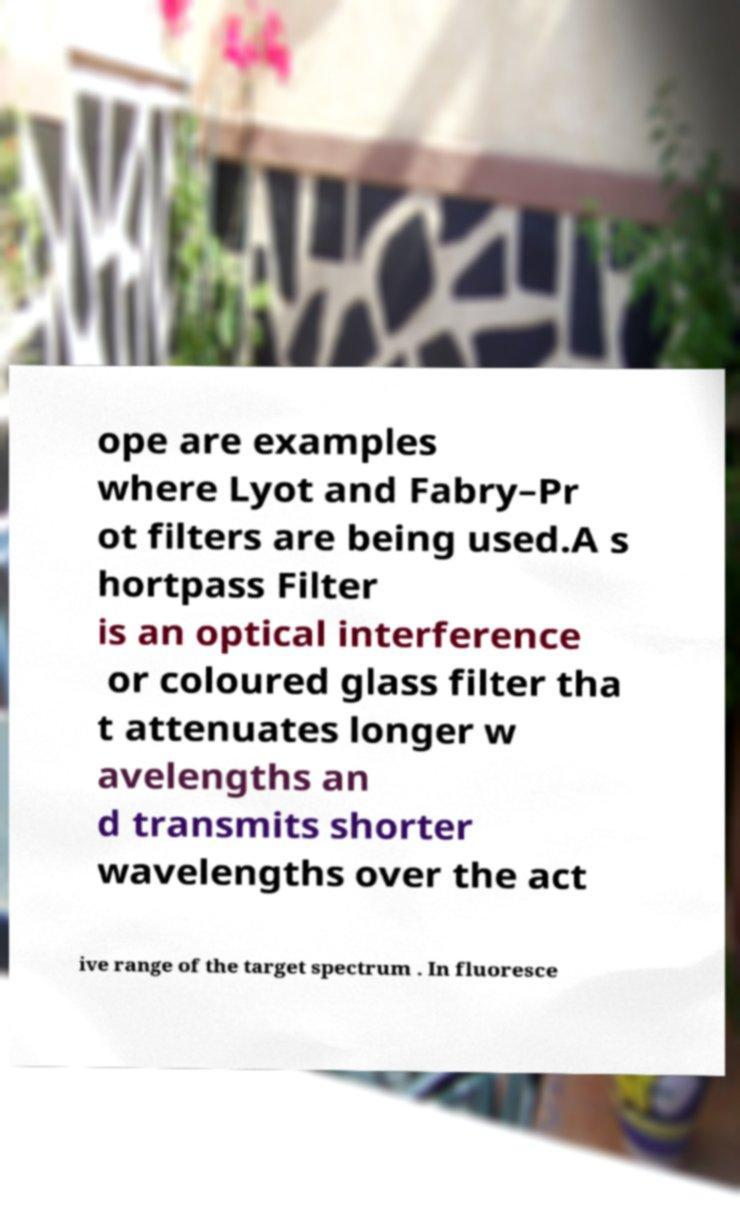Could you extract and type out the text from this image? ope are examples where Lyot and Fabry–Pr ot filters are being used.A s hortpass Filter is an optical interference or coloured glass filter tha t attenuates longer w avelengths an d transmits shorter wavelengths over the act ive range of the target spectrum . In fluoresce 